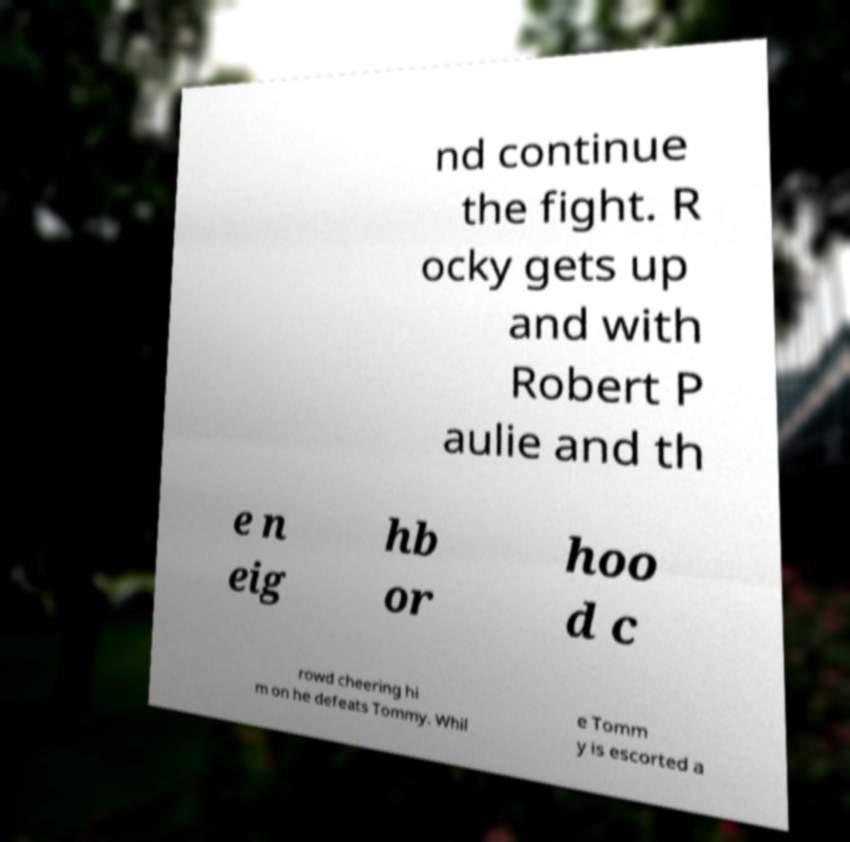There's text embedded in this image that I need extracted. Can you transcribe it verbatim? nd continue the fight. R ocky gets up and with Robert P aulie and th e n eig hb or hoo d c rowd cheering hi m on he defeats Tommy. Whil e Tomm y is escorted a 